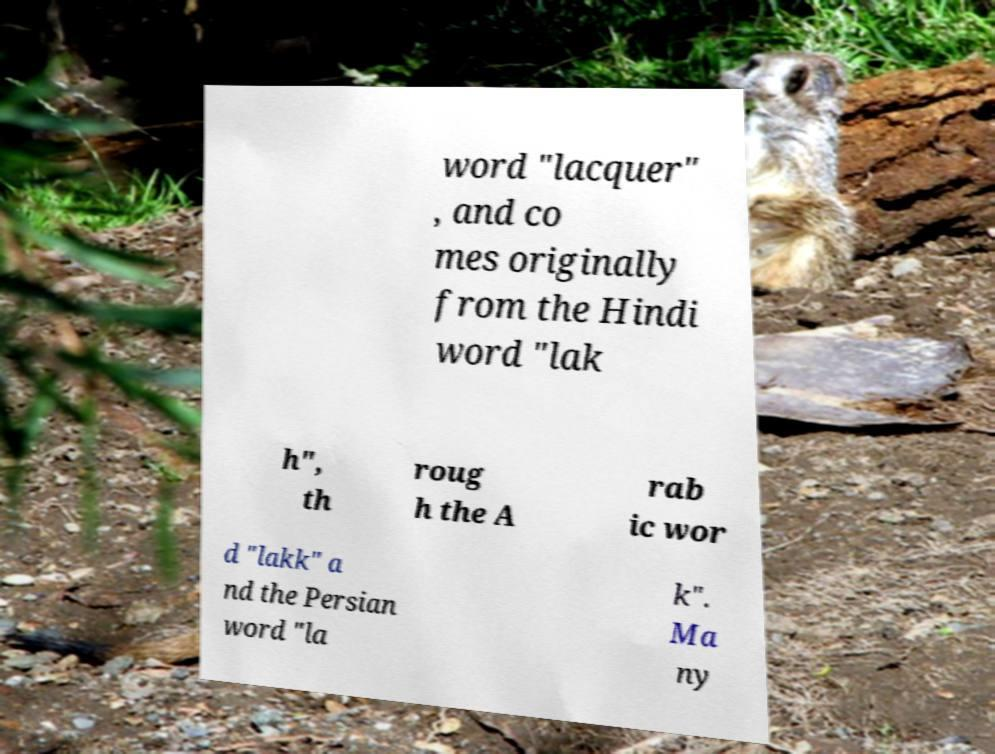Can you accurately transcribe the text from the provided image for me? word "lacquer" , and co mes originally from the Hindi word "lak h", th roug h the A rab ic wor d "lakk" a nd the Persian word "la k". Ma ny 